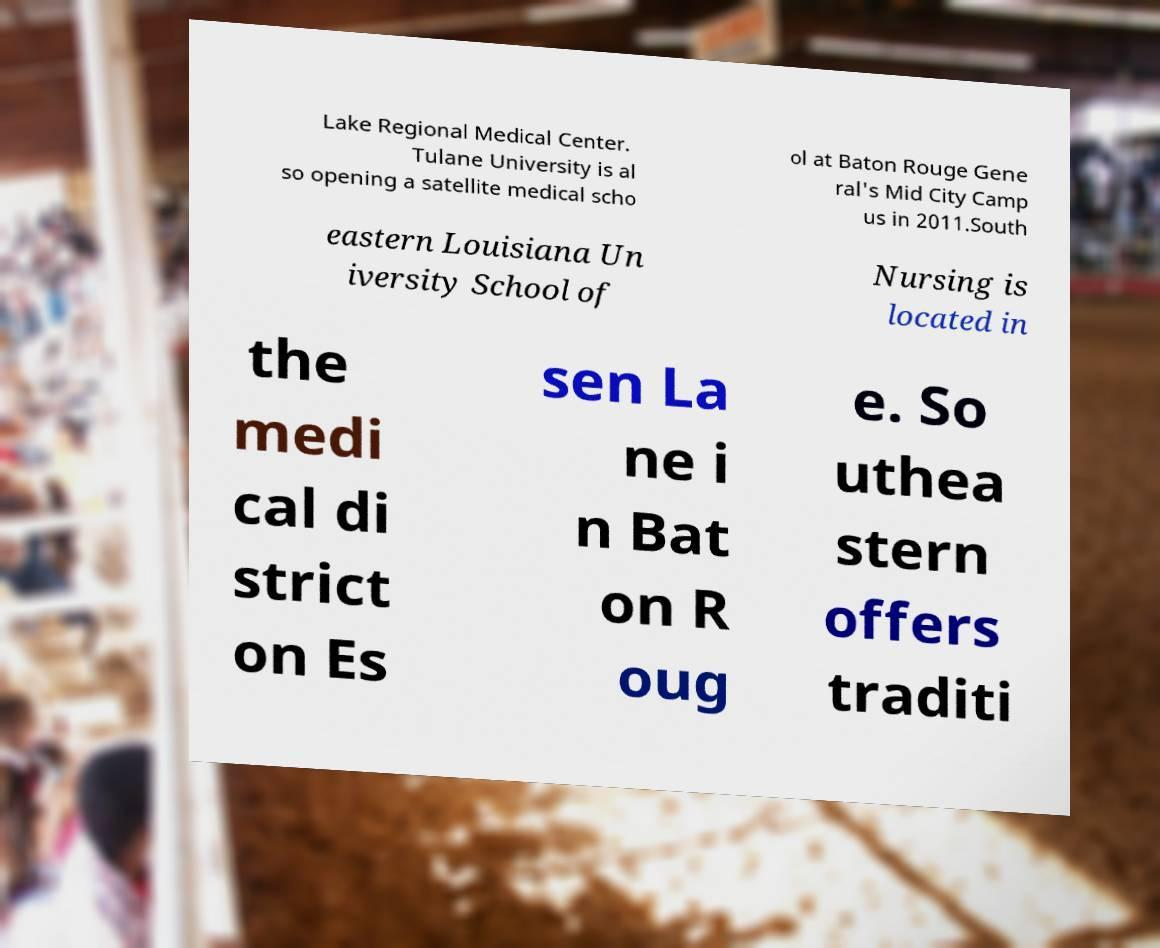I need the written content from this picture converted into text. Can you do that? Lake Regional Medical Center. Tulane University is al so opening a satellite medical scho ol at Baton Rouge Gene ral's Mid City Camp us in 2011.South eastern Louisiana Un iversity School of Nursing is located in the medi cal di strict on Es sen La ne i n Bat on R oug e. So uthea stern offers traditi 